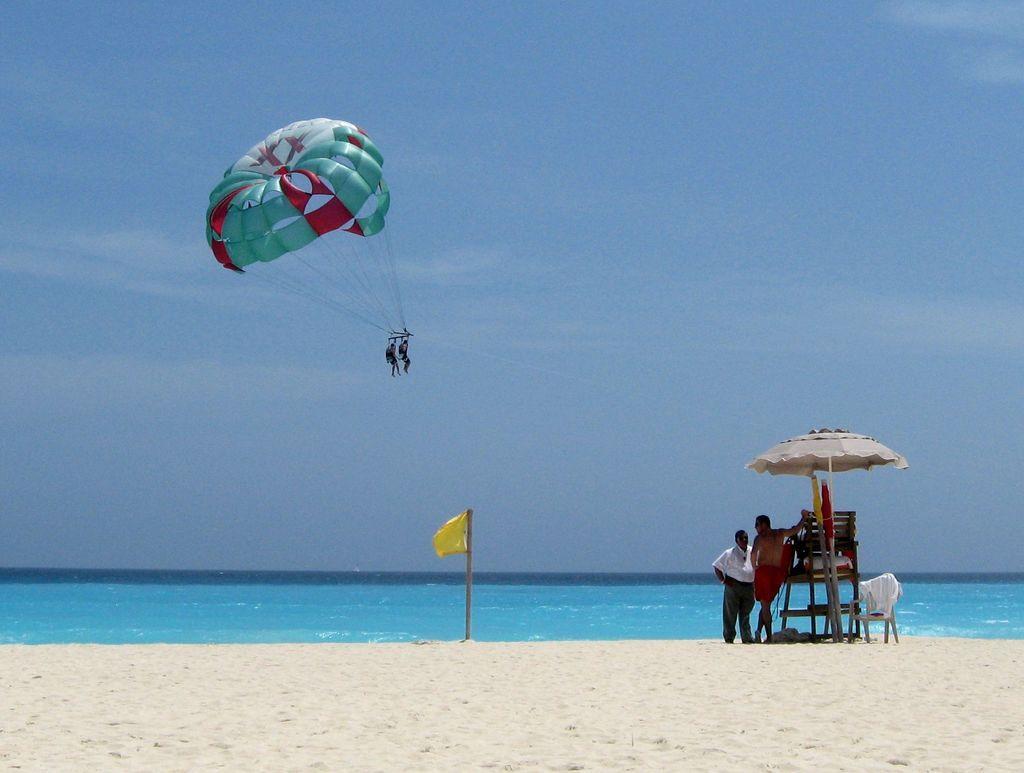Please provide a concise description of this image. In this image there is a sandy land, on that land there are two people standing and there are chairs and an umbrella, in the background there is the sea, flag at the top there is a parachute, two persons are in the parachute and there is the sky. 